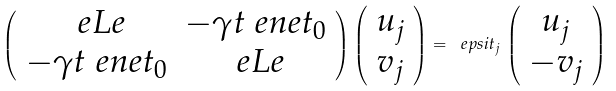Convert formula to latex. <formula><loc_0><loc_0><loc_500><loc_500>\left ( \begin{array} { c c } \ e L e & - \gamma t \ e n e t _ { 0 } \\ - \gamma t \ e n e t _ { 0 } & \ e L e \end{array} \right ) \left ( \begin{array} { c c } u _ { j } \\ v _ { j } \end{array} \right ) = \ e p s i t _ { j } \, \left ( \begin{array} { c c } u _ { j } \\ - v _ { j } \end{array} \right )</formula> 